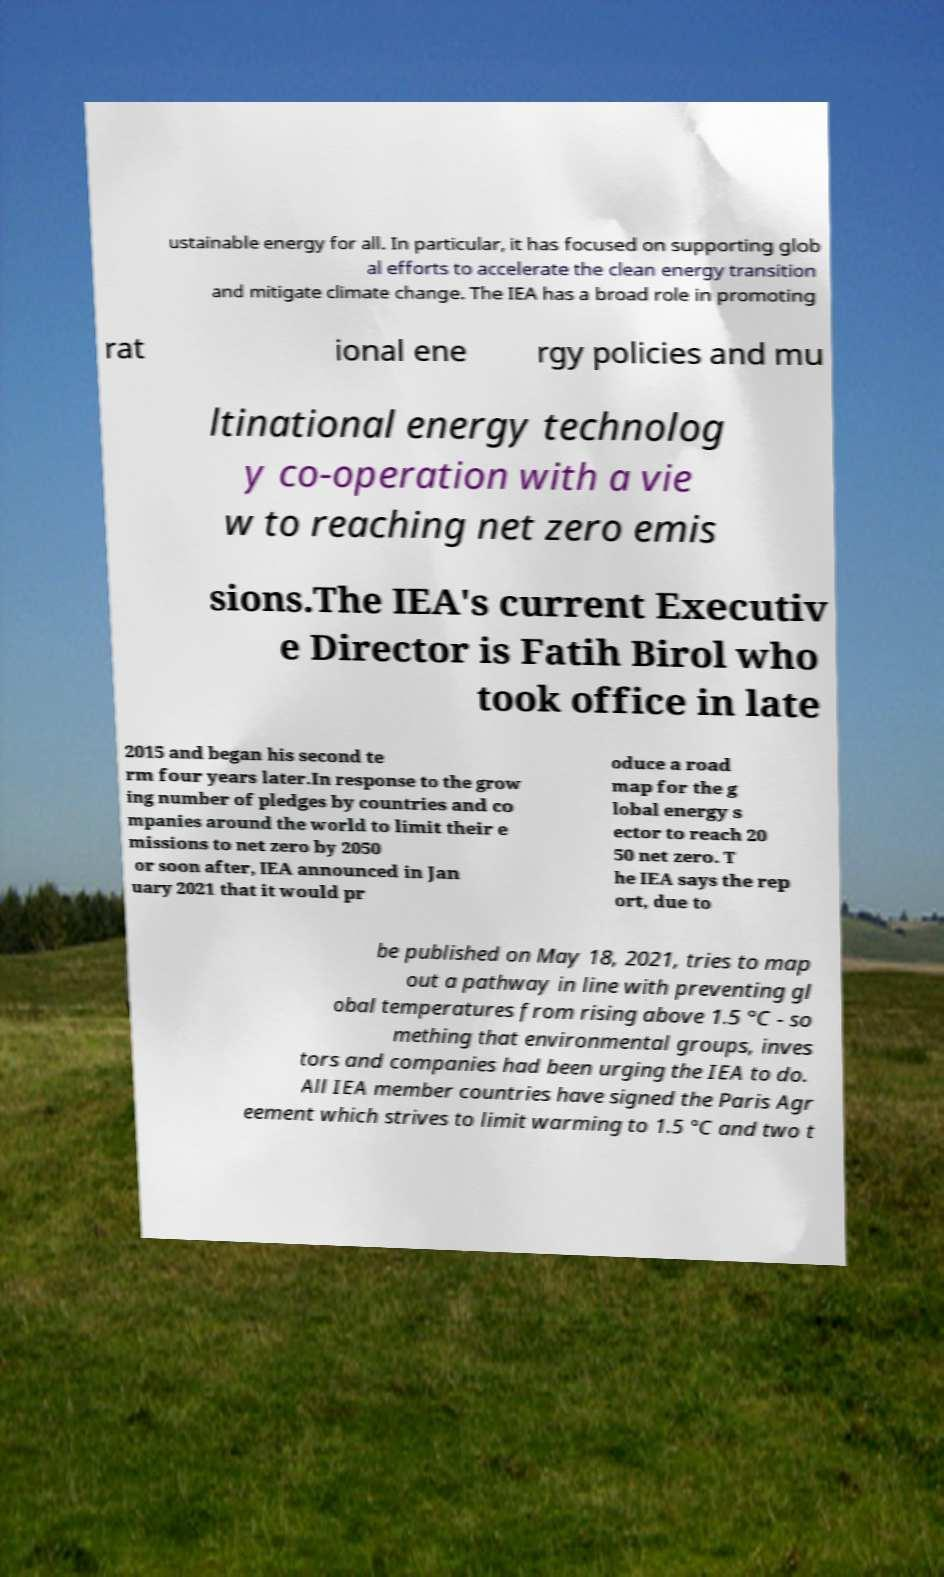Could you assist in decoding the text presented in this image and type it out clearly? ustainable energy for all. In particular, it has focused on supporting glob al efforts to accelerate the clean energy transition and mitigate climate change. The IEA has a broad role in promoting rat ional ene rgy policies and mu ltinational energy technolog y co-operation with a vie w to reaching net zero emis sions.The IEA's current Executiv e Director is Fatih Birol who took office in late 2015 and began his second te rm four years later.In response to the grow ing number of pledges by countries and co mpanies around the world to limit their e missions to net zero by 2050 or soon after, IEA announced in Jan uary 2021 that it would pr oduce a road map for the g lobal energy s ector to reach 20 50 net zero. T he IEA says the rep ort, due to be published on May 18, 2021, tries to map out a pathway in line with preventing gl obal temperatures from rising above 1.5 °C - so mething that environmental groups, inves tors and companies had been urging the IEA to do. All IEA member countries have signed the Paris Agr eement which strives to limit warming to 1.5 °C and two t 